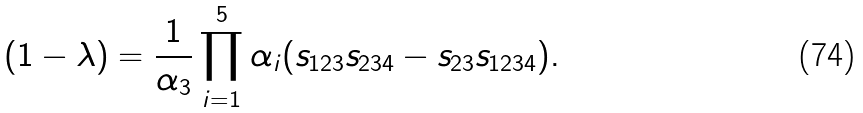<formula> <loc_0><loc_0><loc_500><loc_500>( 1 - \lambda ) = \frac { 1 } { \alpha _ { 3 } } \prod _ { i = 1 } ^ { 5 } \alpha _ { i } ( s _ { 1 2 3 } s _ { 2 3 4 } - s _ { 2 3 } s _ { 1 2 3 4 } ) .</formula> 